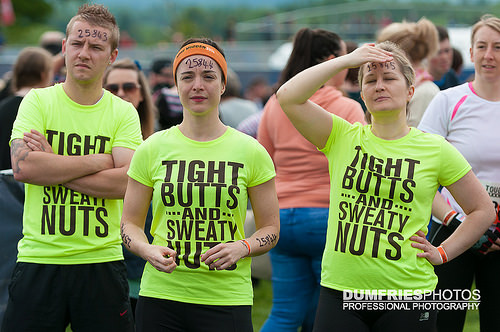<image>
Is the woman behind the man? Yes. From this viewpoint, the woman is positioned behind the man, with the man partially or fully occluding the woman. Where is the lips in relation to the shirt lettering? Is it in front of the shirt lettering? No. The lips is not in front of the shirt lettering. The spatial positioning shows a different relationship between these objects. 